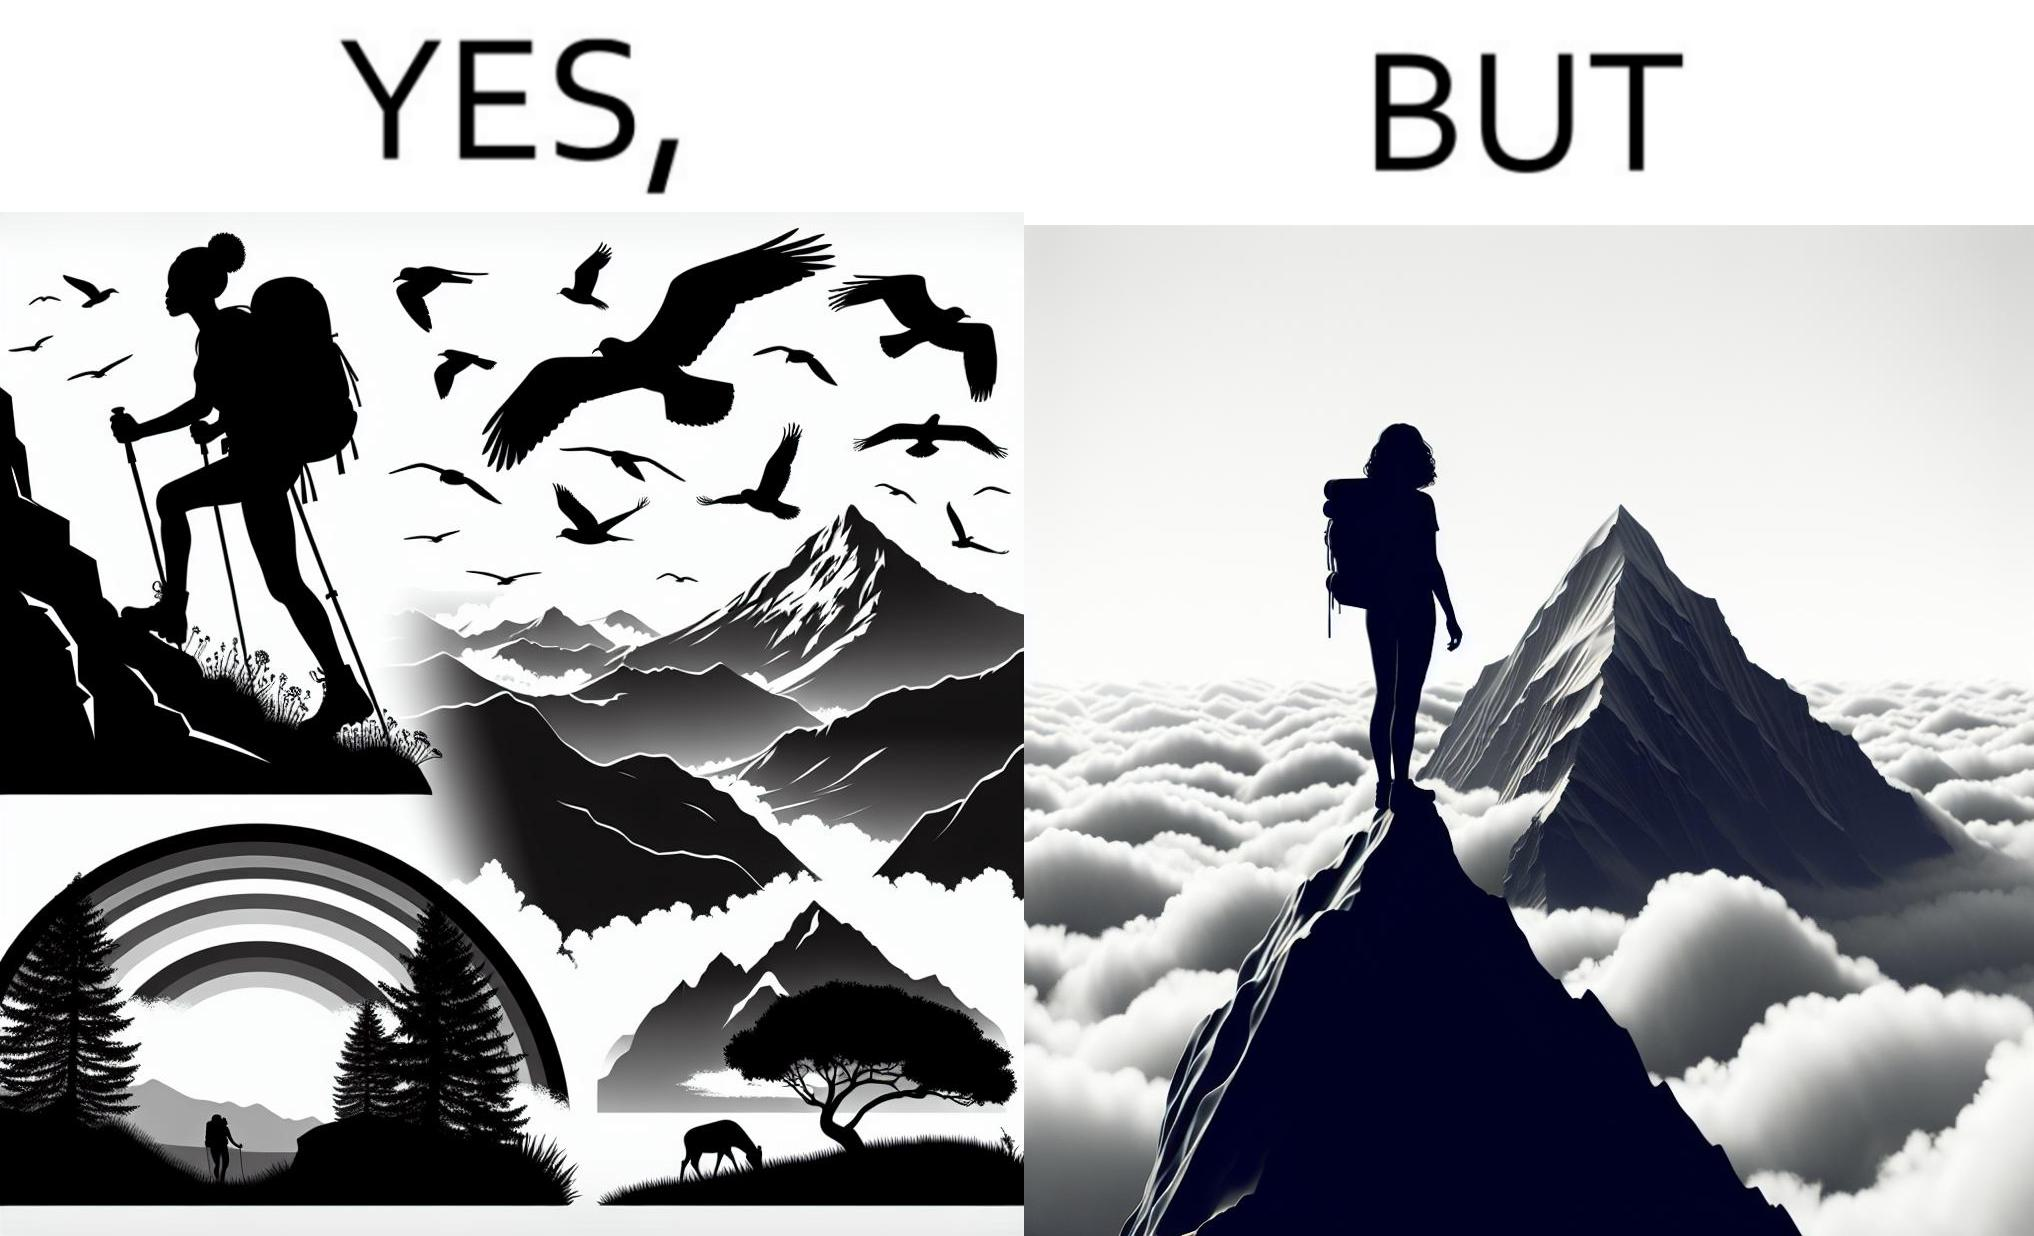Compare the left and right sides of this image. In the left part of the image: a mountaineer climbing up the mountain, enjoying the view, birds are flying, rainbow is visible In the right part of the image: a mountaineer is at the peak of the mountain but nothing is visible due to clouds 